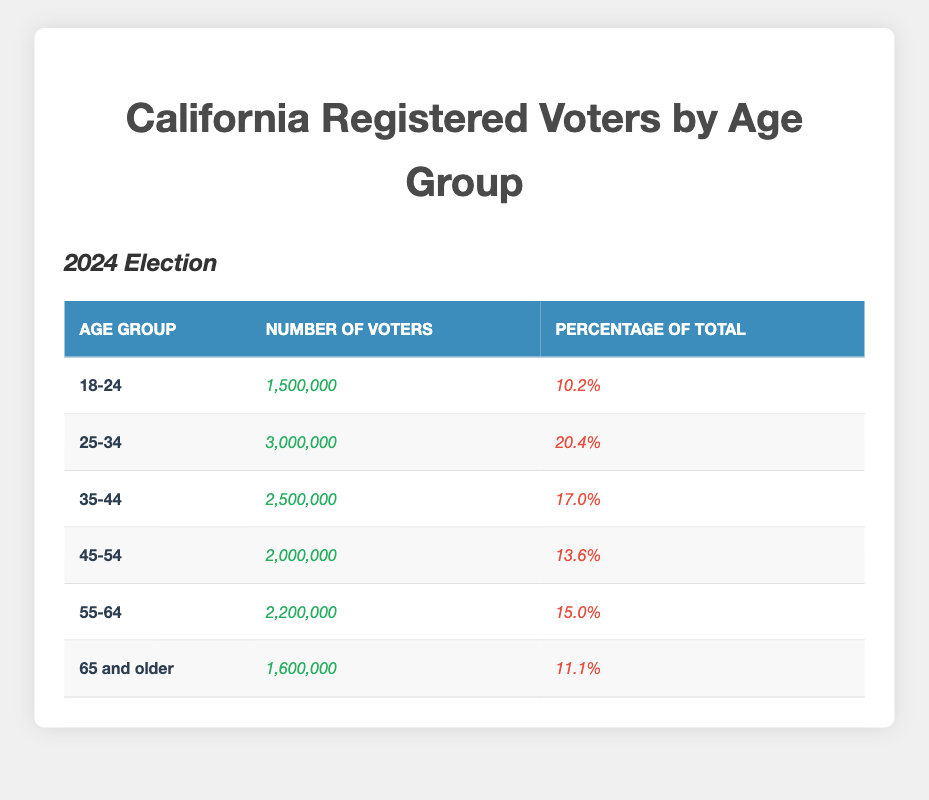What is the age group with the highest number of registered voters? The table lists the age groups and corresponding number of voters. By comparing the numbers, I see that the age group "25-34" has the highest number of registered voters at 3,000,000.
Answer: 25-34 What percentage of total voters are aged 18-24? The table indicates that the "18-24" age group represents 10.2% of the total registered voters, which is displayed alongside their number of voters.
Answer: 10.2% How many registered voters are in the "55-64" age group? From the table, the "55-64" age group lists 2,200,000 registered voters explicitly.
Answer: 2,200,000 What is the total number of voters across all age groups? To find the total, I add the number of voters from all age groups: 1,500,000 + 3,000,000 + 2,500,000 + 2,000,000 + 2,200,000 + 1,600,000 = 12,800,000.
Answer: 12,800,000 Which age group has the lowest percentage of registered voters? The table shows that the age group "18-24" has the lowest percentage at 10.2%.
Answer: 18-24 Is the number of voters in the "35-44" age group more than the "45-54" age group? By comparing the two age groups' voter numbers, I see that "35-44" has 2,500,000 voters and "45-54" has 2,000,000 voters. Therefore, "35-44" has more voters than "45-54."
Answer: Yes What is the difference in number of registered voters between the "25-34" and "45-54" age groups? The "25-34" group has 3,000,000 voters, while the "45-54" group has 2,000,000 voters. The difference is 3,000,000 - 2,000,000 = 1,000,000.
Answer: 1,000,000 What percentage of the total registered voters are aged 65 and older? The table states that the "65 and older" age group has 11.1% of total registered voters, making this the percentage for this group.
Answer: 11.1% If we combine the "45-54" and "55-64" age groups, what percentage do they represent of the total registered voters? Their combined voter count is 2,000,000 + 2,200,000 = 4,200,000. To find the percentage, I divide 4,200,000 by the total number of voters (12,800,000) and multiply by 100: (4,200,000 / 12,800,000) * 100 = 32.8%.
Answer: 32.8% Which age group's percentage of total voters is closest to 15%? The "55-64" age group has a percentage of 15.0%, which is exactly 15%, whereas no other group is this close to that figure.
Answer: 55-64 